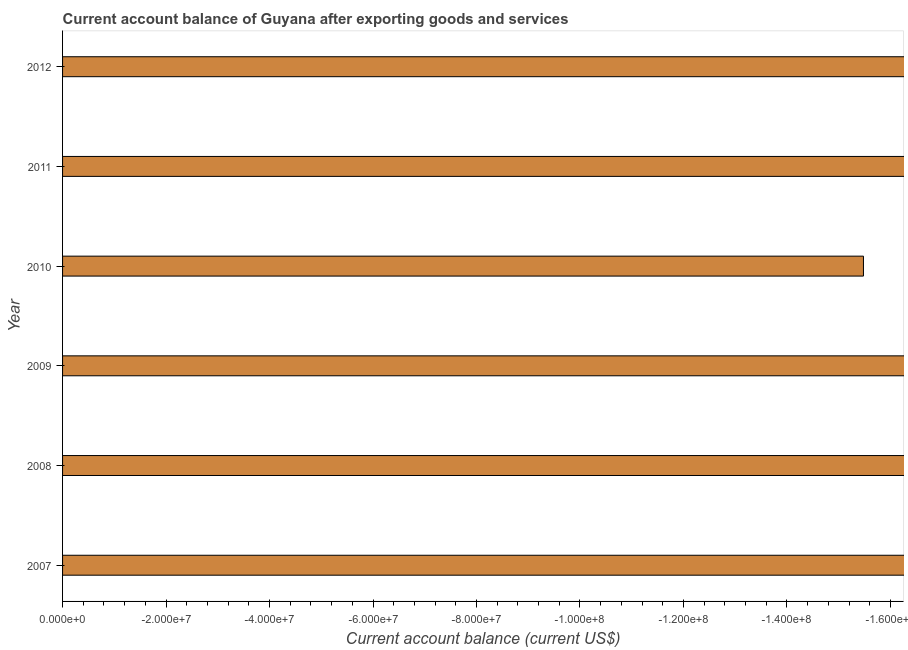Does the graph contain any zero values?
Keep it short and to the point. Yes. Does the graph contain grids?
Offer a terse response. No. What is the title of the graph?
Offer a very short reply. Current account balance of Guyana after exporting goods and services. What is the label or title of the X-axis?
Your answer should be compact. Current account balance (current US$). Across all years, what is the minimum current account balance?
Offer a very short reply. 0. What is the average current account balance per year?
Ensure brevity in your answer.  0. What is the median current account balance?
Give a very brief answer. 0. In how many years, is the current account balance greater than the average current account balance taken over all years?
Your response must be concise. 0. How many bars are there?
Your answer should be very brief. 0. What is the Current account balance (current US$) of 2007?
Your response must be concise. 0. What is the Current account balance (current US$) of 2012?
Keep it short and to the point. 0. 